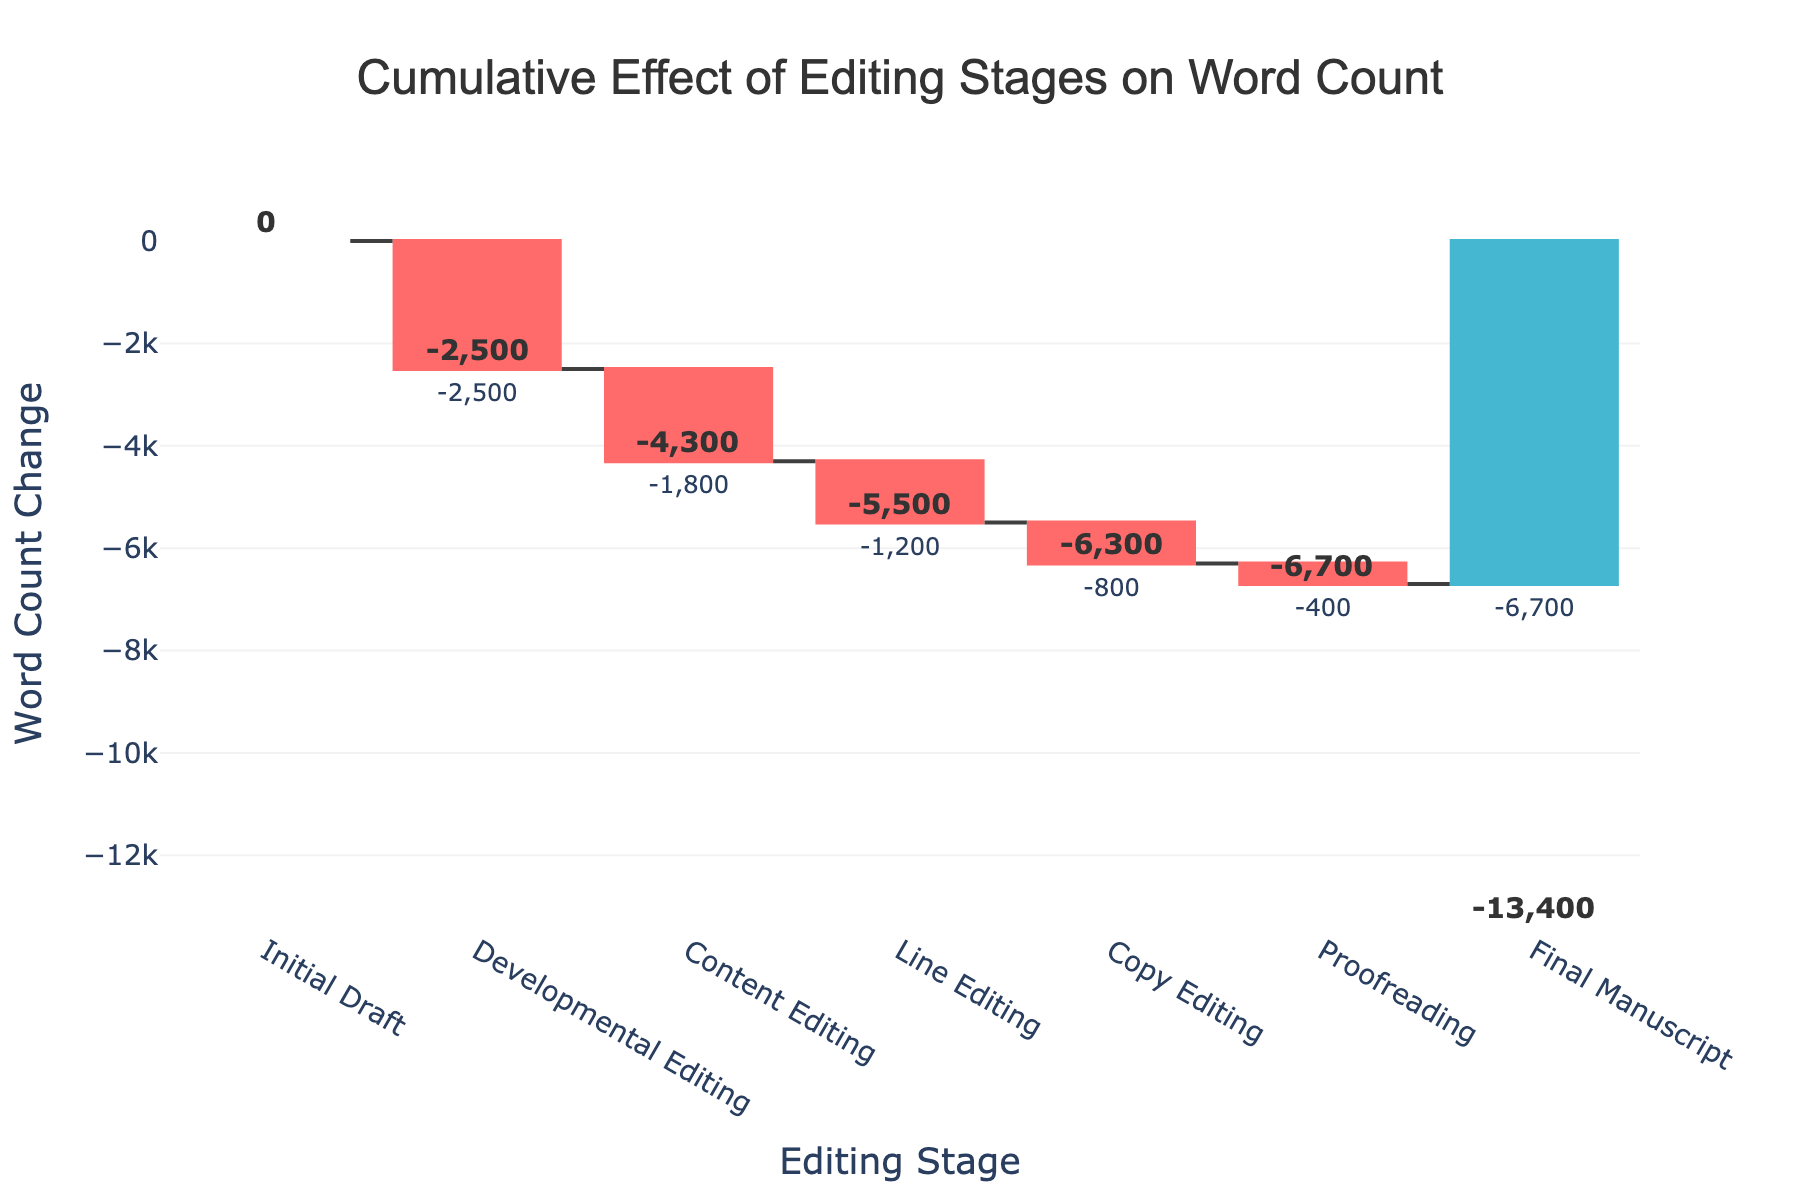What is the overall title of the chart? The chart title is present at the top center of the figure and gives an overview of what the chart represents.
Answer: Cumulative Effect of Editing Stages on Word Count How many editing stages are represented in the chart? You can count the labels along the x-axis to determine the number of stages.
Answer: 6 What is the total word count change from the Initial Draft to the Final Manuscript? The final cumulative value after all editing stages gives the total word count change. Looking at the label "Final Manuscript," the value shows -6700, indicating the net reduction.
Answer: -6700 Which editing stage results in the largest word count reduction? Comparisons can be made by looking at the bars' lengths representing each editing stage. Developmental Editing has the longest bar.
Answer: Developmental Editing What is the cumulative word count reduction after Line Editing? To find this, observe the cumulative word count label associated with "Line Editing."
Answer: -5500 Which two stages together account for the largest cumulative word count reduction? You need to add the two largest word count reductions and ignore the overlaps, checking pairs for the highest sum. Developmental Editing (-2500) and Content Editing (-1800).
Answer: Developmental Editing and Content Editing At which editing stage is the minor word count change observed? Find the stage with the smallest bar height excluding "Final Manuscript". Proofreading has the smallest reduction.
Answer: Proofreading When does the word count first exceed half of the total reduction observed? Half of the total reduction is -3350. You need to identify the stage at which the cumulative reduction exceeds -3350, which occurs at Content Editing (-4300).
Answer: Content Editing By how much does Copy Editing reduce the word count? Check the label next to the bar for Copy Editing; it shows -800.
Answer: -800 